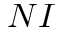Convert formula to latex. <formula><loc_0><loc_0><loc_500><loc_500>N I</formula> 